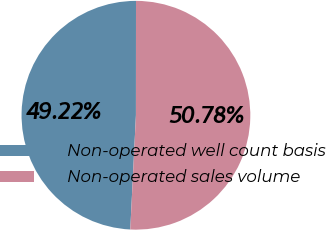Convert chart to OTSL. <chart><loc_0><loc_0><loc_500><loc_500><pie_chart><fcel>Non-operated well count basis<fcel>Non-operated sales volume<nl><fcel>49.22%<fcel>50.78%<nl></chart> 